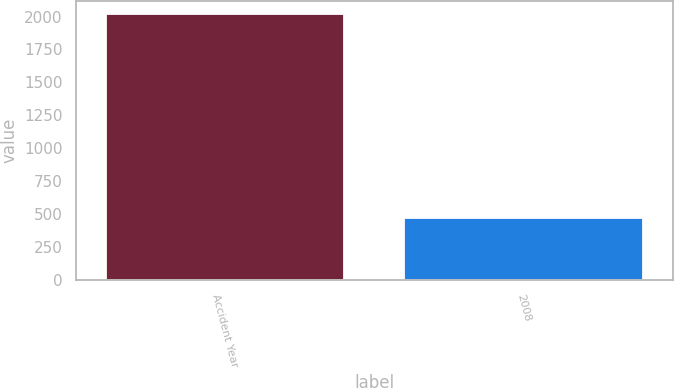Convert chart to OTSL. <chart><loc_0><loc_0><loc_500><loc_500><bar_chart><fcel>Accident Year<fcel>2008<nl><fcel>2017<fcel>465<nl></chart> 